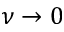Convert formula to latex. <formula><loc_0><loc_0><loc_500><loc_500>\nu \to 0</formula> 